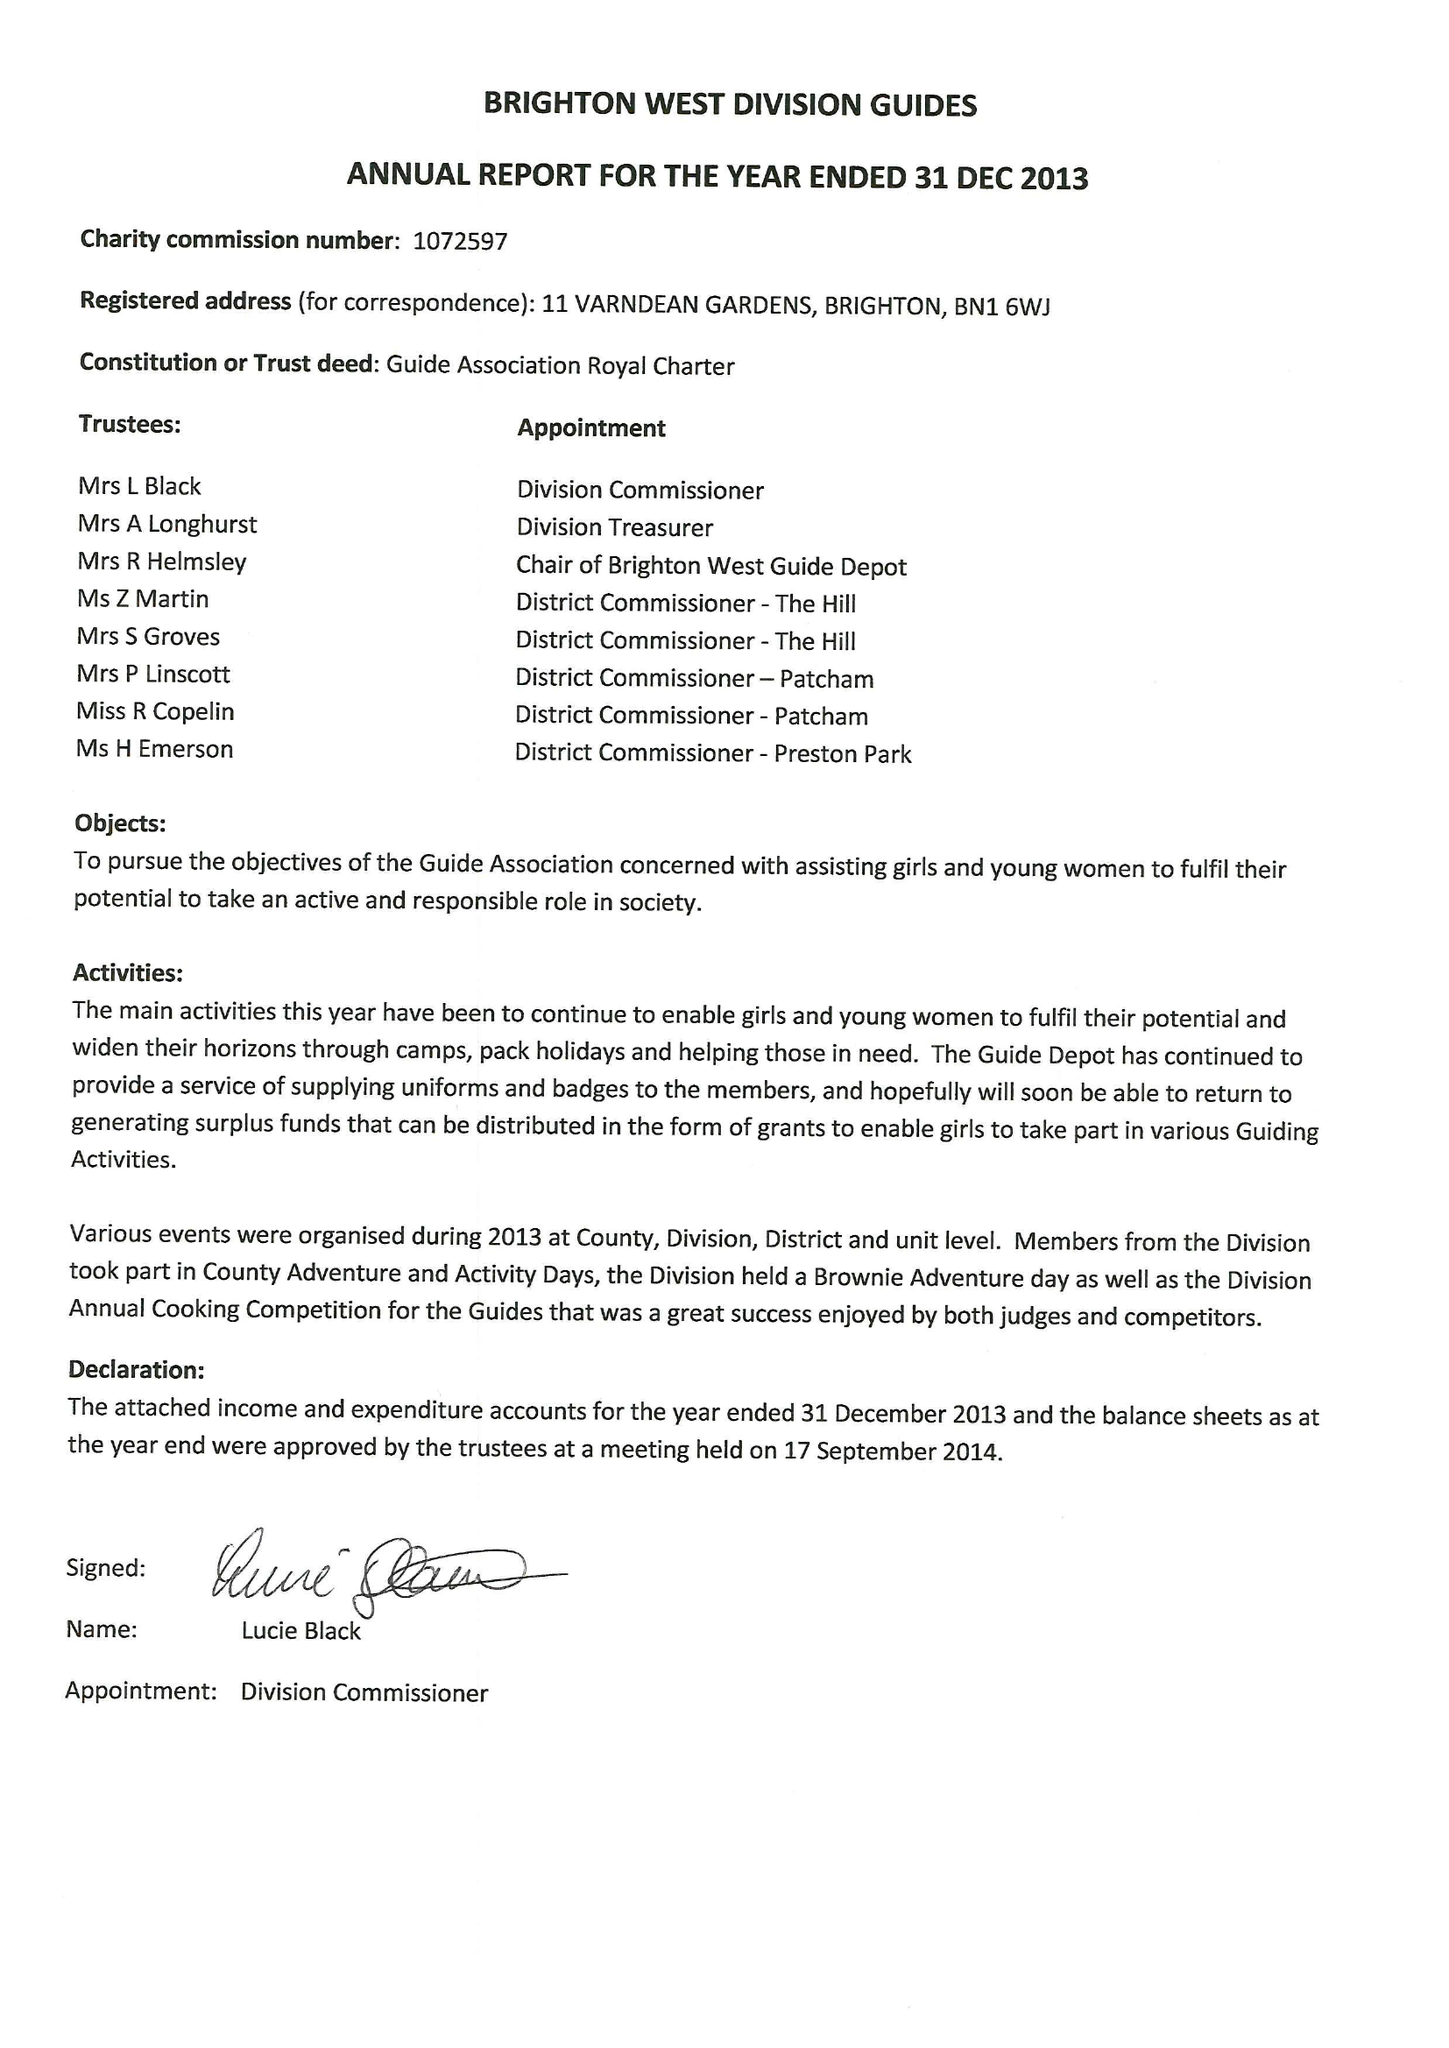What is the value for the address__post_town?
Answer the question using a single word or phrase. BRIGHTON 